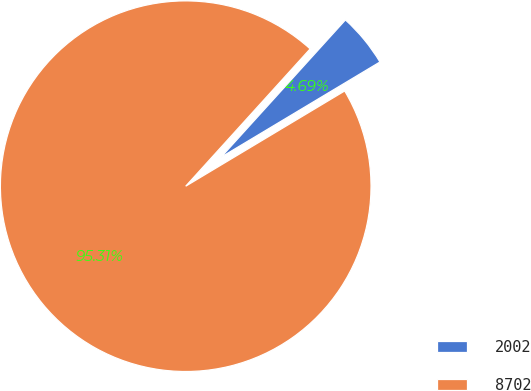Convert chart to OTSL. <chart><loc_0><loc_0><loc_500><loc_500><pie_chart><fcel>2002<fcel>8702<nl><fcel>4.69%<fcel>95.31%<nl></chart> 